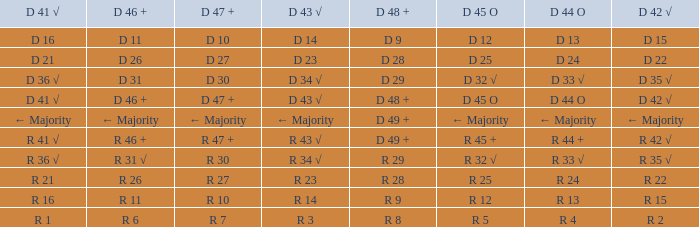What is the value of D 45 O, when the value of D 41 √ is r 41 √? R 45 +. 